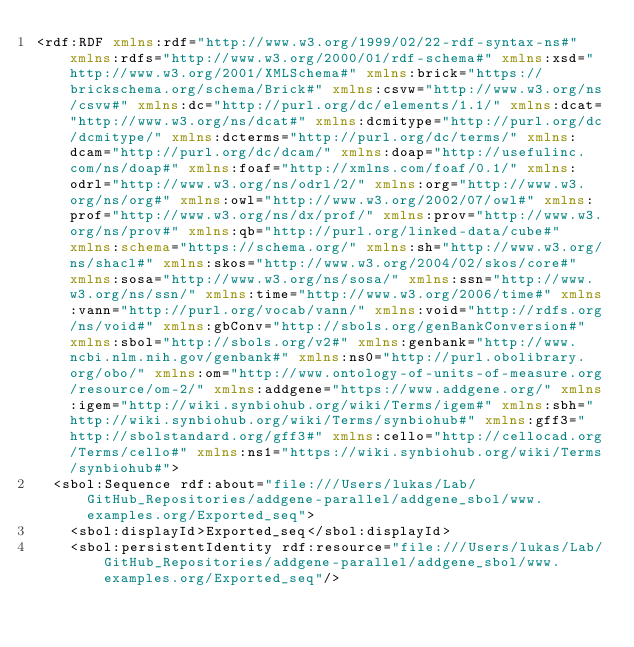Convert code to text. <code><loc_0><loc_0><loc_500><loc_500><_XML_><rdf:RDF xmlns:rdf="http://www.w3.org/1999/02/22-rdf-syntax-ns#" xmlns:rdfs="http://www.w3.org/2000/01/rdf-schema#" xmlns:xsd="http://www.w3.org/2001/XMLSchema#" xmlns:brick="https://brickschema.org/schema/Brick#" xmlns:csvw="http://www.w3.org/ns/csvw#" xmlns:dc="http://purl.org/dc/elements/1.1/" xmlns:dcat="http://www.w3.org/ns/dcat#" xmlns:dcmitype="http://purl.org/dc/dcmitype/" xmlns:dcterms="http://purl.org/dc/terms/" xmlns:dcam="http://purl.org/dc/dcam/" xmlns:doap="http://usefulinc.com/ns/doap#" xmlns:foaf="http://xmlns.com/foaf/0.1/" xmlns:odrl="http://www.w3.org/ns/odrl/2/" xmlns:org="http://www.w3.org/ns/org#" xmlns:owl="http://www.w3.org/2002/07/owl#" xmlns:prof="http://www.w3.org/ns/dx/prof/" xmlns:prov="http://www.w3.org/ns/prov#" xmlns:qb="http://purl.org/linked-data/cube#" xmlns:schema="https://schema.org/" xmlns:sh="http://www.w3.org/ns/shacl#" xmlns:skos="http://www.w3.org/2004/02/skos/core#" xmlns:sosa="http://www.w3.org/ns/sosa/" xmlns:ssn="http://www.w3.org/ns/ssn/" xmlns:time="http://www.w3.org/2006/time#" xmlns:vann="http://purl.org/vocab/vann/" xmlns:void="http://rdfs.org/ns/void#" xmlns:gbConv="http://sbols.org/genBankConversion#" xmlns:sbol="http://sbols.org/v2#" xmlns:genbank="http://www.ncbi.nlm.nih.gov/genbank#" xmlns:ns0="http://purl.obolibrary.org/obo/" xmlns:om="http://www.ontology-of-units-of-measure.org/resource/om-2/" xmlns:addgene="https://www.addgene.org/" xmlns:igem="http://wiki.synbiohub.org/wiki/Terms/igem#" xmlns:sbh="http://wiki.synbiohub.org/wiki/Terms/synbiohub#" xmlns:gff3="http://sbolstandard.org/gff3#" xmlns:cello="http://cellocad.org/Terms/cello#" xmlns:ns1="https://wiki.synbiohub.org/wiki/Terms/synbiohub#">
  <sbol:Sequence rdf:about="file:///Users/lukas/Lab/GitHub_Repositories/addgene-parallel/addgene_sbol/www.examples.org/Exported_seq">
    <sbol:displayId>Exported_seq</sbol:displayId>
    <sbol:persistentIdentity rdf:resource="file:///Users/lukas/Lab/GitHub_Repositories/addgene-parallel/addgene_sbol/www.examples.org/Exported_seq"/></code> 